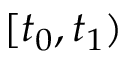<formula> <loc_0><loc_0><loc_500><loc_500>[ t _ { 0 } , t _ { 1 } )</formula> 